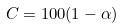Convert formula to latex. <formula><loc_0><loc_0><loc_500><loc_500>C = 1 0 0 ( 1 - \alpha ) \</formula> 